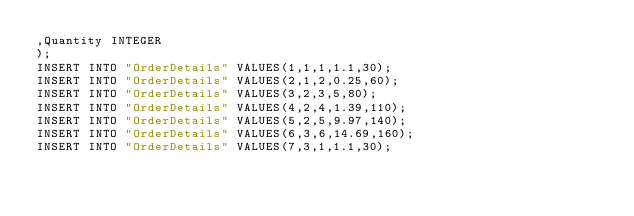<code> <loc_0><loc_0><loc_500><loc_500><_SQL_>,Quantity INTEGER
);
INSERT INTO "OrderDetails" VALUES(1,1,1,1.1,30);
INSERT INTO "OrderDetails" VALUES(2,1,2,0.25,60);
INSERT INTO "OrderDetails" VALUES(3,2,3,5,80);
INSERT INTO "OrderDetails" VALUES(4,2,4,1.39,110);
INSERT INTO "OrderDetails" VALUES(5,2,5,9.97,140);
INSERT INTO "OrderDetails" VALUES(6,3,6,14.69,160);
INSERT INTO "OrderDetails" VALUES(7,3,1,1.1,30);</code> 